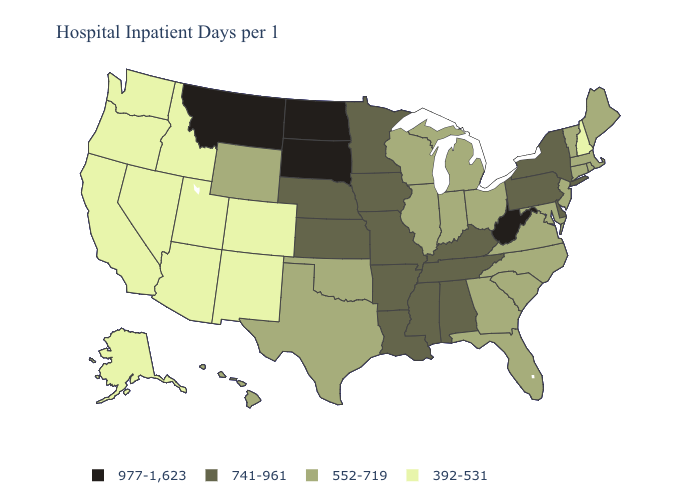Among the states that border Maryland , does Delaware have the highest value?
Short answer required. No. Does Alaska have a lower value than Arizona?
Concise answer only. No. What is the value of Pennsylvania?
Write a very short answer. 741-961. Is the legend a continuous bar?
Concise answer only. No. Name the states that have a value in the range 392-531?
Give a very brief answer. Alaska, Arizona, California, Colorado, Idaho, Nevada, New Hampshire, New Mexico, Oregon, Utah, Washington. What is the value of Wyoming?
Concise answer only. 552-719. What is the value of Maine?
Quick response, please. 552-719. What is the value of Iowa?
Be succinct. 741-961. Which states have the lowest value in the South?
Answer briefly. Florida, Georgia, Maryland, North Carolina, Oklahoma, South Carolina, Texas, Virginia. Name the states that have a value in the range 977-1,623?
Write a very short answer. Montana, North Dakota, South Dakota, West Virginia. What is the lowest value in the USA?
Answer briefly. 392-531. Name the states that have a value in the range 392-531?
Keep it brief. Alaska, Arizona, California, Colorado, Idaho, Nevada, New Hampshire, New Mexico, Oregon, Utah, Washington. What is the value of Virginia?
Be succinct. 552-719. Does the first symbol in the legend represent the smallest category?
Write a very short answer. No. What is the value of Arkansas?
Short answer required. 741-961. 